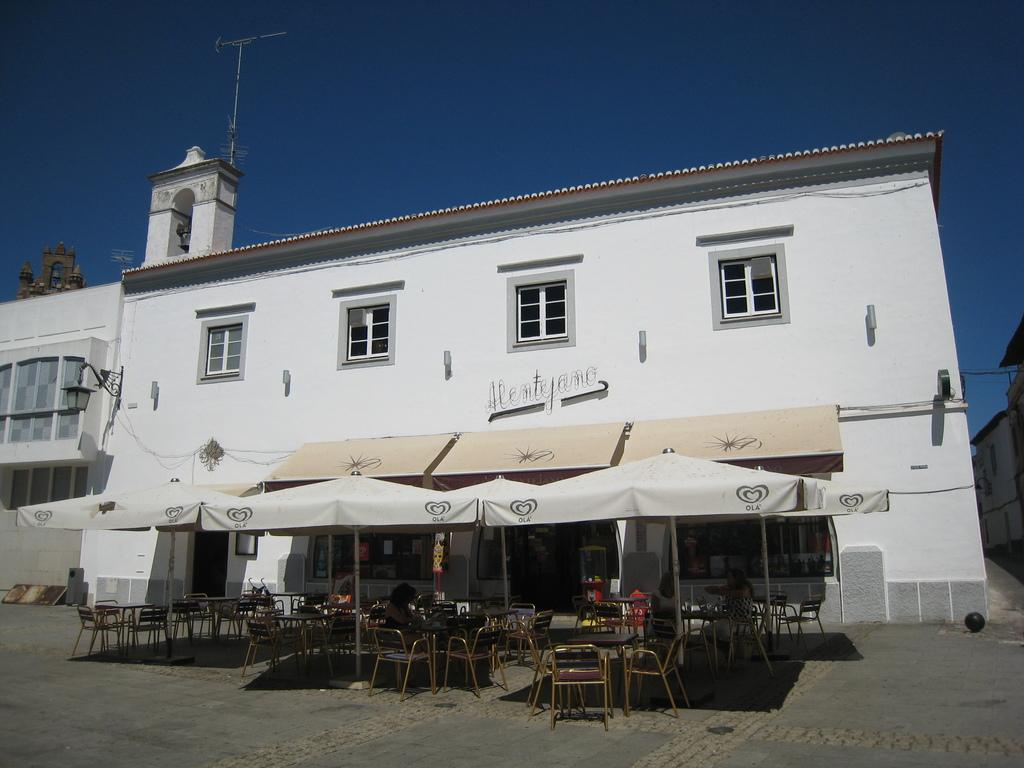What type of structures can be seen in the image? There are buildings in the image. What architectural features are visible on the buildings? There are windows visible on the buildings. What type of furniture is present in the image? There are chairs and tables in the image. What is the purpose of the light pole in the image? The light pole provides illumination in the image. What type of businesses are present in the image? There are stores in the image. What type of weather is suggested by the presence of umbrellas in the image? The presence of umbrellas suggests that it might be raining or overcast in the image. What color is the sky in the image? The sky is blue in the image. What type of lettuce is being used as a question mark in the image? There is no lettuce present in the image, and therefore no such use of lettuce can be observed. What type of umbrella is being used as a hat in the image? There is no umbrella being used as a hat in the image; the umbrellas are being used for their intended purpose of providing shelter from the weather. 